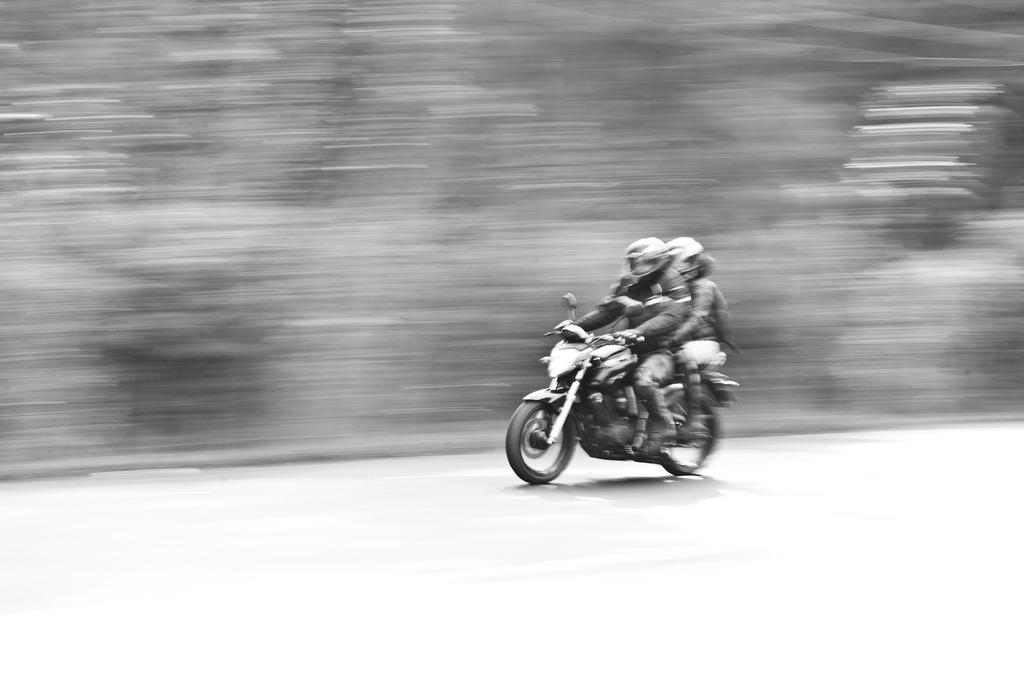How many people are in the image? There are two persons in the image. What are the two persons doing in the image? The two persons are riding a bike. What safety precautions are the two persons taking in the image? Both persons are wearing helmets. What type of basketball shoes can be seen on the governor during the meeting in the image? There is no governor or meeting present in the image, and therefore no basketball shoes can be observed. 